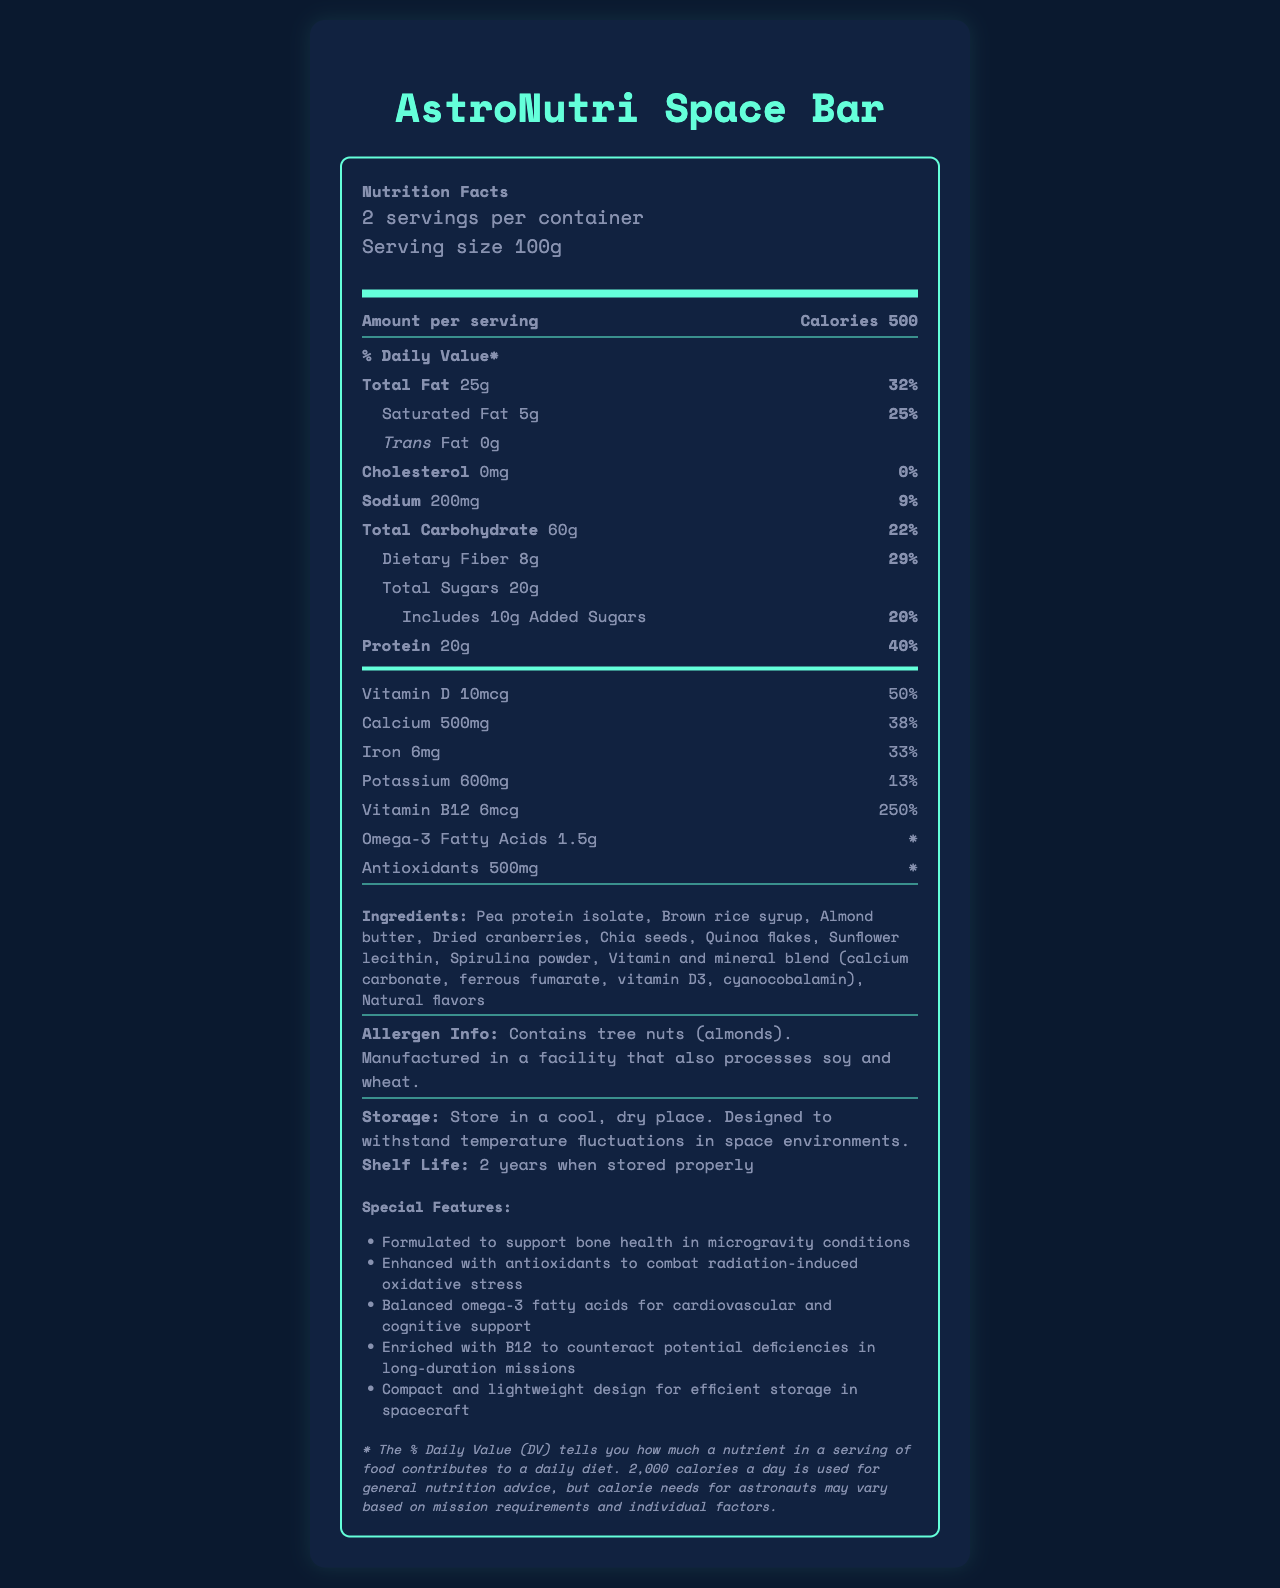who is the manufacturer of the AstroNutri Space Bar? The document does not provide any information about the manufacturer of the AstroNutri Space Bar.
Answer: Cannot be determined how many grams of protein are in one serving of the AstroNutri Space Bar? The Nutrition Facts section states that there are 20g of protein per serving.
Answer: 20g what is the daily value percentage for Vitamin D in the AstroNutri Space Bar? The Nutrition Facts section shows that the daily value percentage for Vitamin D is 50%.
Answer: 50% how much sodium is there per serving? The Nutrition Facts section lists 200mg of sodium per serving.
Answer: 200mg what type of special features does this space bar offer? The document lists the special features such as supporting bone health in microgravity conditions, enhanced with antioxidants, balanced omega-3 fatty acids, enrichment with B12, and a compact and lightweight design.
Answer: Supports bone health, enhanced with antioxidants, balanced omega-3 fatty acids, enriched with B12, compact and lightweight design how many calories does one container of the AstroNutri Space Bar contain? Since each container has 2 servings and each serving has 500 calories, the total is 500 calories/serving × 2 servings = 1000 calories.
Answer: 1000 calories does the AstroNutri Space Bar contain any tree nuts? The allergen information states that the bar contains tree nuts (almonds).
Answer: Yes how is the product designed to handle space environments? A. By adding preservatives B. By making it lightweight C. By allowing it to withstand temperature fluctuations D. By vacuum sealing The storage instructions indicate that the bar is designed to withstand temperature fluctuations in space environments.
Answer: C what is the main carbohydrate source in the list of ingredients? A. Brown rice syrup B. Pea protein isolate C. Sunflower lecithin D. Spirulina powder Brown rice syrup is listed as the second ingredient after pea protein isolate, marking it as a significant carbohydrate source.
Answer: A what key nutrient combats potential B12 deficiency in long-duration missions? The special features indicate that the product is enriched with B12 to counteract potential deficiencies during long-duration missions.
Answer: Vitamin B12 summarize the Nutrition Facts of the AstroNutri Space Bar. The bar is formulated to meet the dietary needs of astronauts, with emphasis on providing high energy, protein, essential vitamins, minerals, and special features to support various health aspects in space.
Answer: The AstroNutri Space Bar provides essential nutrients for astronauts, including 500 calories per serving, 20g of protein, and substantial daily values of vitamins and minerals. It contains 25% daily value of saturated fat, no cholesterol, and notable amounts of sodium and carbohydrates. Special features support bone health, antioxidant defense, balanced omega-3 fatty acids, and counteracting B12 deficiency. It is compact, lightweight, and designed for space environment storage. is the calorie information based on standard daily dietary advice for astronauts? The notes indicate that while the daily values are based on a 2,000 calorie diet, the calorie needs for astronauts may vary based on mission requirements and individual factors.
Answer: No 